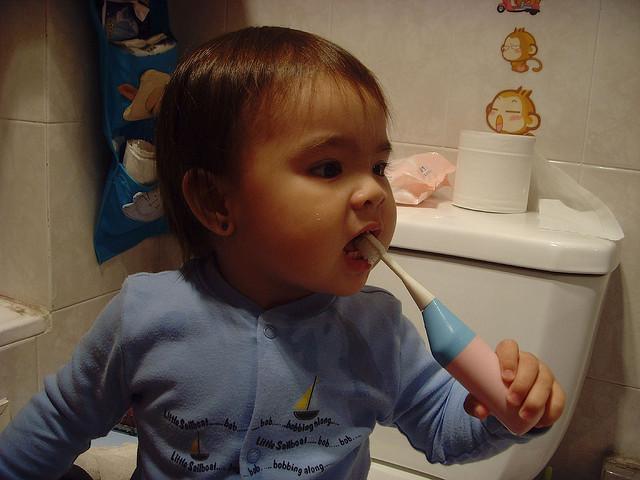What room is this?
Short answer required. Bathroom. Is this kid brushing their teeth?
Answer briefly. Yes. What is the baby doing?
Short answer required. Brushing teeth. What color is the baby's hair?
Give a very brief answer. Brown. Is the boy wearing a funny tie?
Give a very brief answer. No. What hand is the kid holding their toothbrush in?
Short answer required. Left. What is behind the child?
Write a very short answer. Toilet. What is the child looking at?
Keep it brief. Mirror. How many stripes are on the towel?
Concise answer only. 0. What is the boy trying to do?
Keep it brief. Brush teeth. 